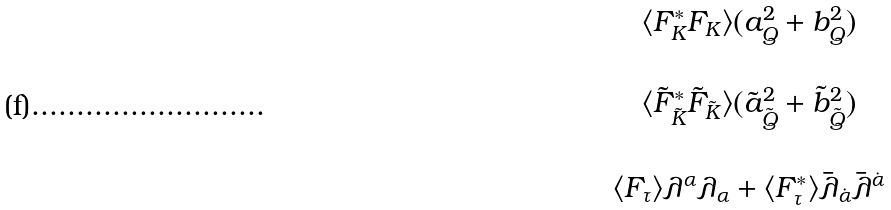Convert formula to latex. <formula><loc_0><loc_0><loc_500><loc_500>\begin{array} { c } \langle F _ { K } ^ { \ast } F _ { K } \rangle ( a _ { Q } ^ { 2 } + b _ { Q } ^ { 2 } ) \\ \\ \langle \tilde { F } _ { \tilde { K } } ^ { \ast } \tilde { F } _ { \tilde { K } } \rangle ( \tilde { a } _ { \tilde { Q } } ^ { 2 } + \tilde { b } _ { \tilde { Q } } ^ { 2 } ) \\ \\ \langle F _ { \tau } \rangle \lambda ^ { \alpha } \lambda _ { \alpha } + \langle F _ { \tau } ^ { \ast } \rangle \bar { \lambda } _ { \dot { \alpha } } \bar { \lambda } ^ { \dot { \alpha } } \end{array}</formula> 